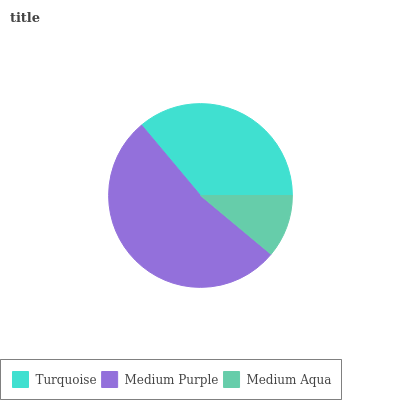Is Medium Aqua the minimum?
Answer yes or no. Yes. Is Medium Purple the maximum?
Answer yes or no. Yes. Is Medium Purple the minimum?
Answer yes or no. No. Is Medium Aqua the maximum?
Answer yes or no. No. Is Medium Purple greater than Medium Aqua?
Answer yes or no. Yes. Is Medium Aqua less than Medium Purple?
Answer yes or no. Yes. Is Medium Aqua greater than Medium Purple?
Answer yes or no. No. Is Medium Purple less than Medium Aqua?
Answer yes or no. No. Is Turquoise the high median?
Answer yes or no. Yes. Is Turquoise the low median?
Answer yes or no. Yes. Is Medium Purple the high median?
Answer yes or no. No. Is Medium Aqua the low median?
Answer yes or no. No. 